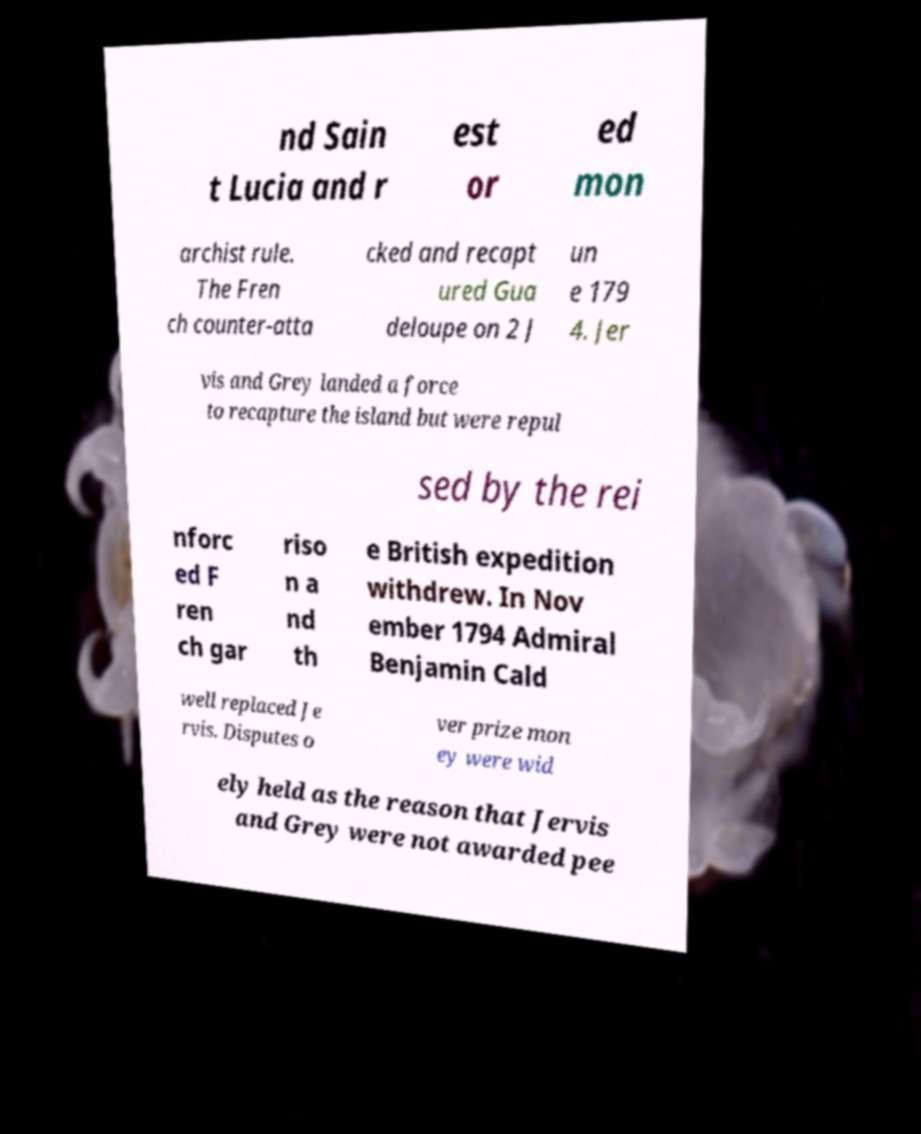I need the written content from this picture converted into text. Can you do that? nd Sain t Lucia and r est or ed mon archist rule. The Fren ch counter-atta cked and recapt ured Gua deloupe on 2 J un e 179 4. Jer vis and Grey landed a force to recapture the island but were repul sed by the rei nforc ed F ren ch gar riso n a nd th e British expedition withdrew. In Nov ember 1794 Admiral Benjamin Cald well replaced Je rvis. Disputes o ver prize mon ey were wid ely held as the reason that Jervis and Grey were not awarded pee 